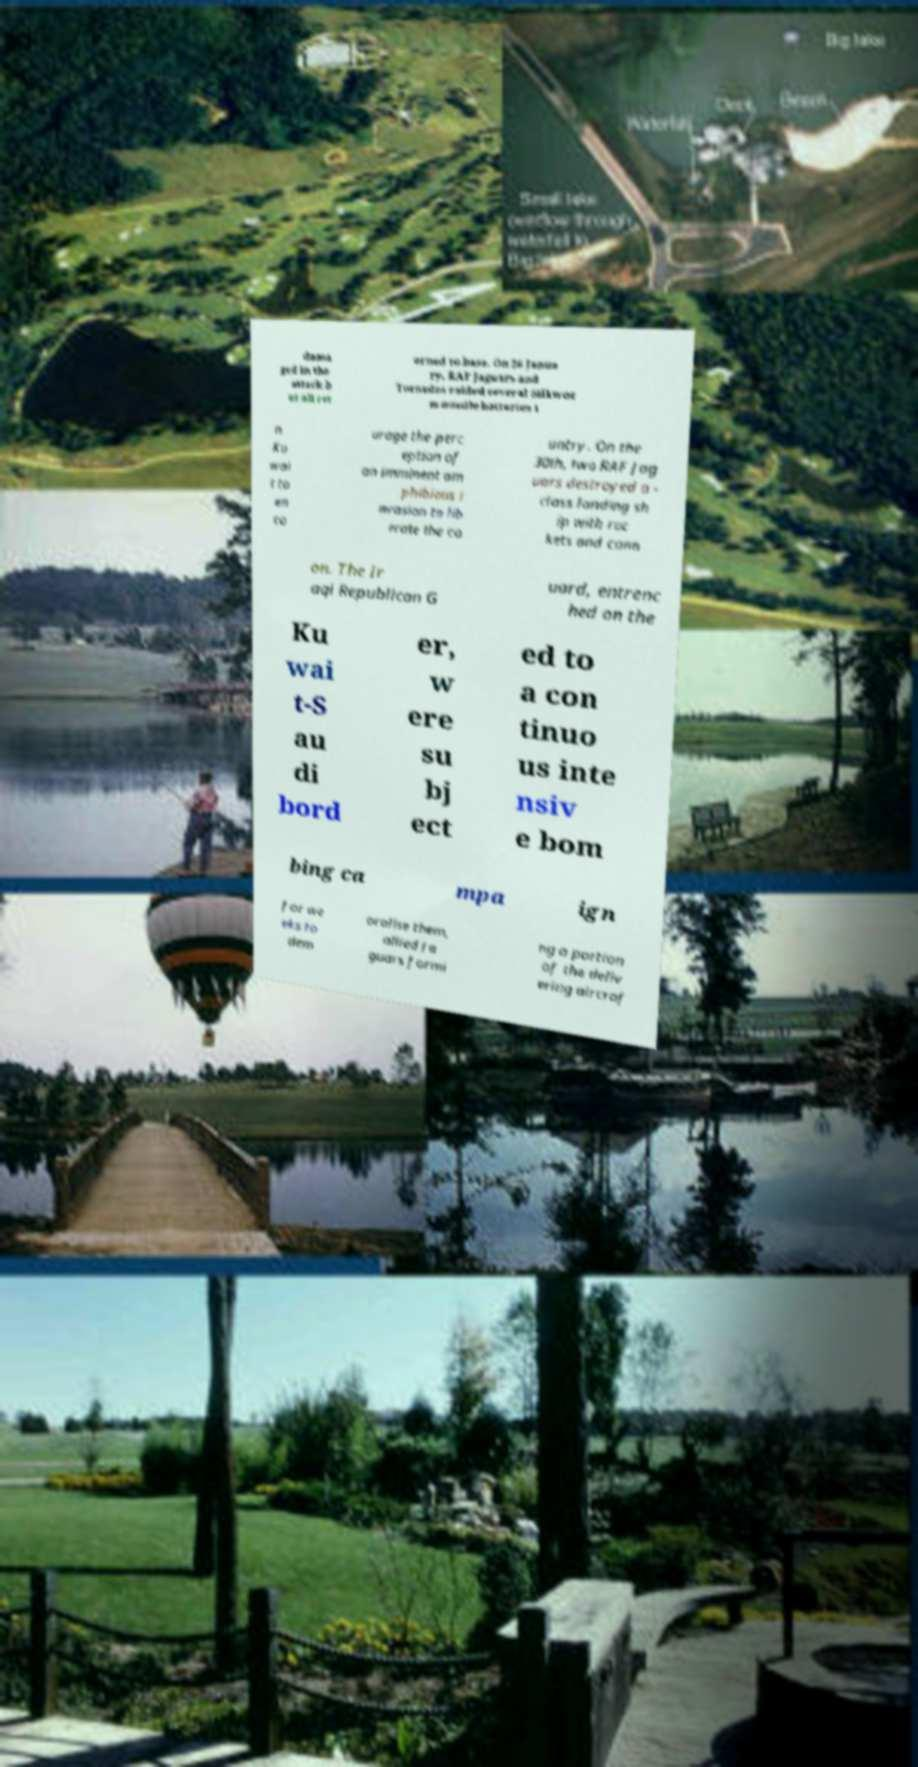Can you read and provide the text displayed in the image?This photo seems to have some interesting text. Can you extract and type it out for me? dama ged in the attack b ut all ret urned to base. On 26 Janua ry, RAF Jaguars and Tornados raided several Silkwor m missile batteries i n Ku wai t to en co urage the perc eption of an imminent am phibious i nvasion to lib erate the co untry. On the 30th, two RAF Jag uars destroyed a - class landing sh ip with roc kets and cann on. The Ir aqi Republican G uard, entrenc hed on the Ku wai t-S au di bord er, w ere su bj ect ed to a con tinuo us inte nsiv e bom bing ca mpa ign for we eks to dem oralise them, allied Ja guars formi ng a portion of the deliv ering aircraf 